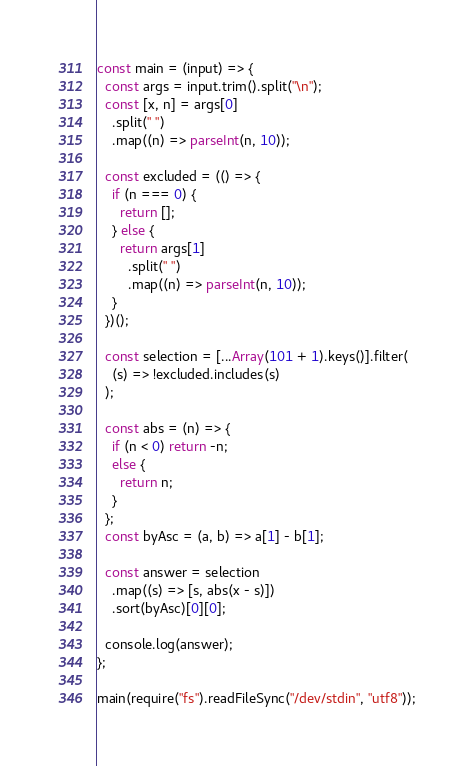<code> <loc_0><loc_0><loc_500><loc_500><_JavaScript_>const main = (input) => {
  const args = input.trim().split("\n");
  const [x, n] = args[0]
    .split(" ")
    .map((n) => parseInt(n, 10));
 
  const excluded = (() => {
    if (n === 0) {
      return [];
    } else {
      return args[1]
        .split(" ")
        .map((n) => parseInt(n, 10));
    }
  })();
 
  const selection = [...Array(101 + 1).keys()].filter(
    (s) => !excluded.includes(s)
  );
 
  const abs = (n) => {
    if (n < 0) return -n;
    else {
      return n;
    }
  };
  const byAsc = (a, b) => a[1] - b[1];
 
  const answer = selection
    .map((s) => [s, abs(x - s)])
    .sort(byAsc)[0][0];
 
  console.log(answer);
};
 
main(require("fs").readFileSync("/dev/stdin", "utf8"));</code> 